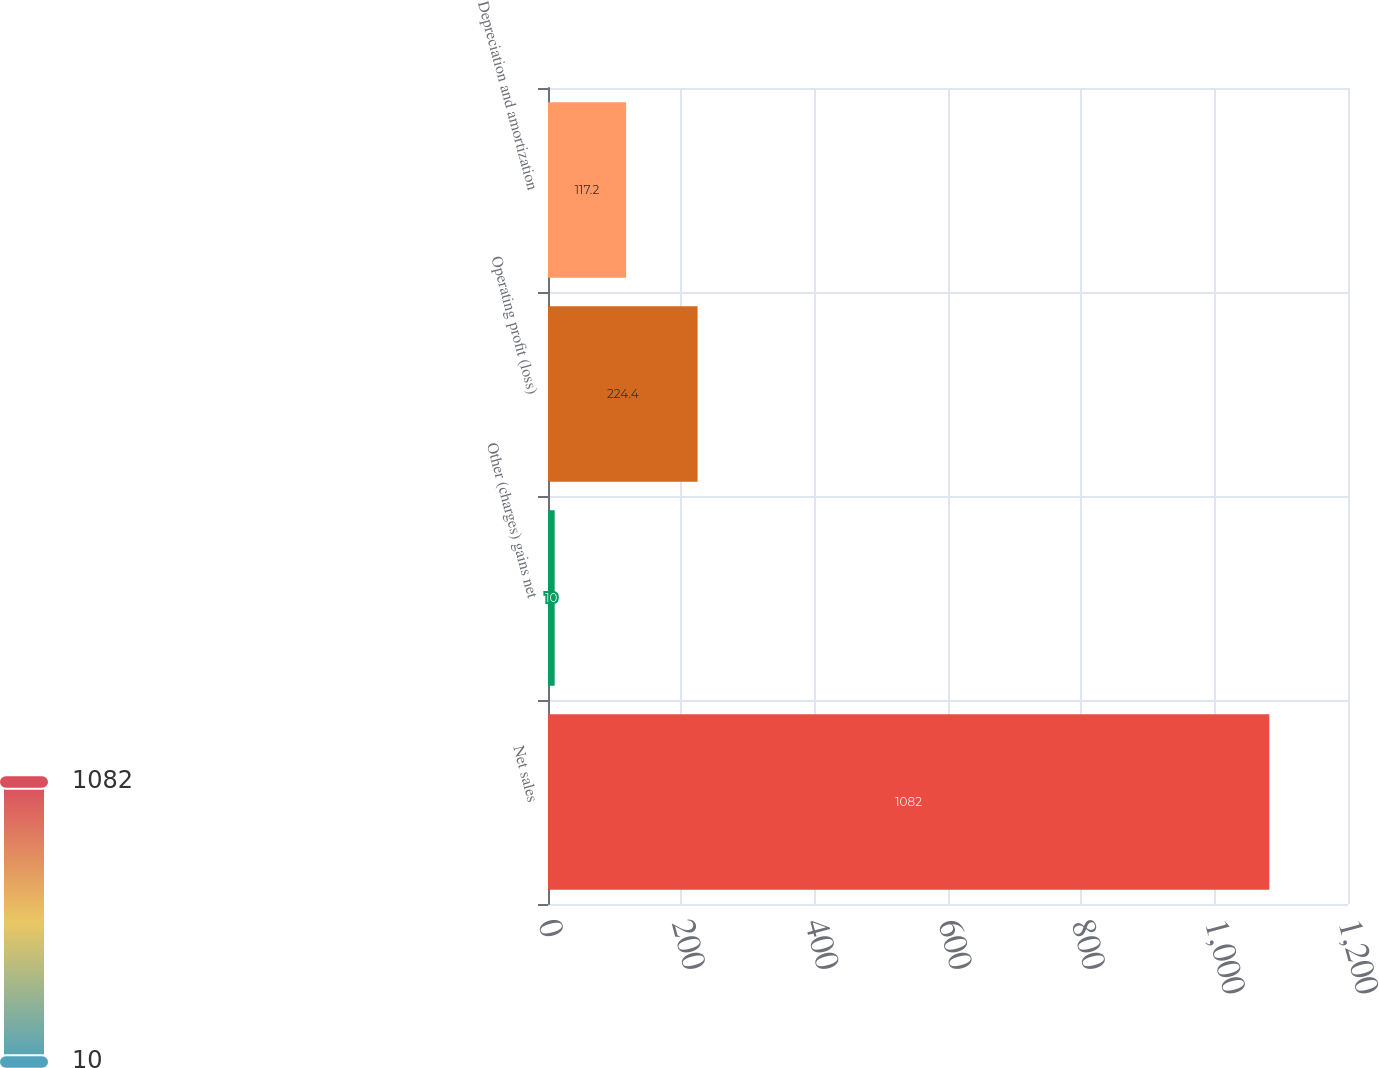<chart> <loc_0><loc_0><loc_500><loc_500><bar_chart><fcel>Net sales<fcel>Other (charges) gains net<fcel>Operating profit (loss)<fcel>Depreciation and amortization<nl><fcel>1082<fcel>10<fcel>224.4<fcel>117.2<nl></chart> 